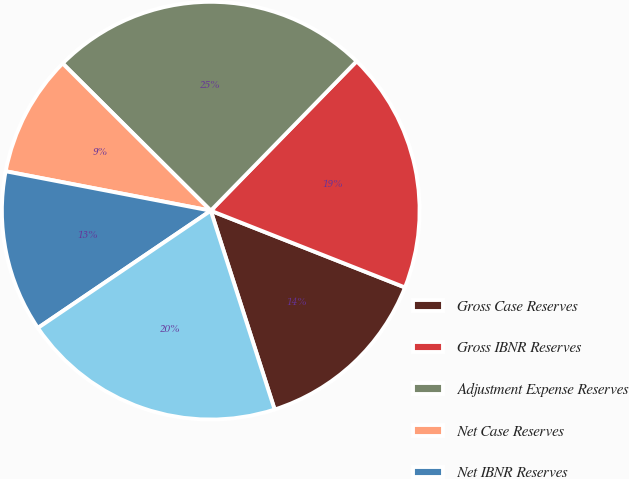Convert chart to OTSL. <chart><loc_0><loc_0><loc_500><loc_500><pie_chart><fcel>Gross Case Reserves<fcel>Gross IBNR Reserves<fcel>Adjustment Expense Reserves<fcel>Net Case Reserves<fcel>Net IBNR Reserves<fcel>Adjustment ExpenseReserves<nl><fcel>14.06%<fcel>18.68%<fcel>24.85%<fcel>9.43%<fcel>12.51%<fcel>20.46%<nl></chart> 